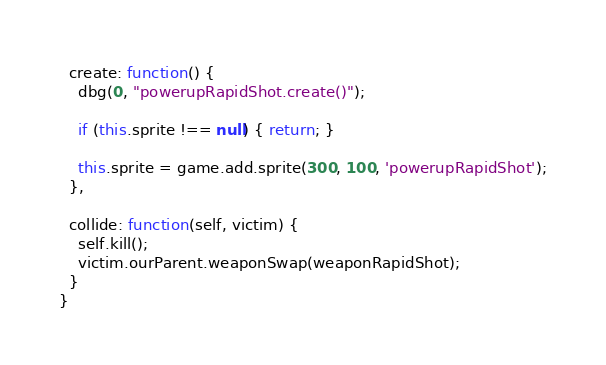Convert code to text. <code><loc_0><loc_0><loc_500><loc_500><_JavaScript_>  create: function() {
    dbg(0, "powerupRapidShot.create()");

    if (this.sprite !== null) { return; }

    this.sprite = game.add.sprite(300, 100, 'powerupRapidShot');
  },

  collide: function(self, victim) {
    self.kill();
    victim.ourParent.weaponSwap(weaponRapidShot);
  }
}
</code> 